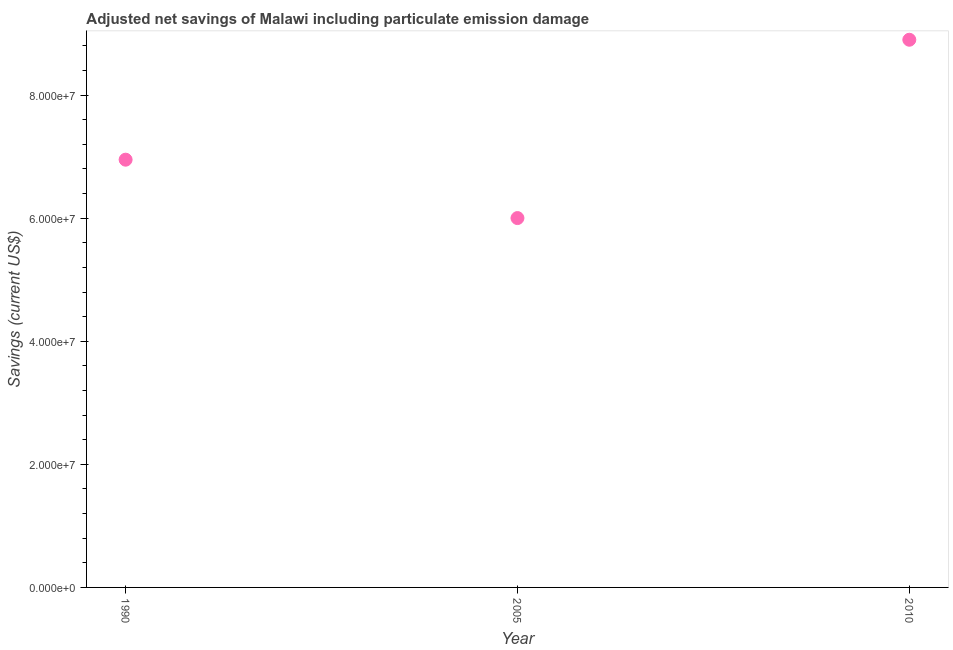What is the adjusted net savings in 2010?
Offer a very short reply. 8.90e+07. Across all years, what is the maximum adjusted net savings?
Provide a short and direct response. 8.90e+07. Across all years, what is the minimum adjusted net savings?
Provide a succinct answer. 6.00e+07. What is the sum of the adjusted net savings?
Your response must be concise. 2.19e+08. What is the difference between the adjusted net savings in 2005 and 2010?
Provide a short and direct response. -2.90e+07. What is the average adjusted net savings per year?
Your answer should be compact. 7.28e+07. What is the median adjusted net savings?
Offer a very short reply. 6.95e+07. In how many years, is the adjusted net savings greater than 52000000 US$?
Your answer should be compact. 3. What is the ratio of the adjusted net savings in 1990 to that in 2005?
Offer a very short reply. 1.16. What is the difference between the highest and the second highest adjusted net savings?
Your response must be concise. 1.95e+07. What is the difference between the highest and the lowest adjusted net savings?
Provide a succinct answer. 2.90e+07. In how many years, is the adjusted net savings greater than the average adjusted net savings taken over all years?
Your answer should be compact. 1. How many dotlines are there?
Offer a very short reply. 1. What is the difference between two consecutive major ticks on the Y-axis?
Make the answer very short. 2.00e+07. Are the values on the major ticks of Y-axis written in scientific E-notation?
Provide a short and direct response. Yes. Does the graph contain any zero values?
Ensure brevity in your answer.  No. Does the graph contain grids?
Ensure brevity in your answer.  No. What is the title of the graph?
Your response must be concise. Adjusted net savings of Malawi including particulate emission damage. What is the label or title of the X-axis?
Provide a succinct answer. Year. What is the label or title of the Y-axis?
Make the answer very short. Savings (current US$). What is the Savings (current US$) in 1990?
Your answer should be very brief. 6.95e+07. What is the Savings (current US$) in 2005?
Offer a terse response. 6.00e+07. What is the Savings (current US$) in 2010?
Make the answer very short. 8.90e+07. What is the difference between the Savings (current US$) in 1990 and 2005?
Offer a very short reply. 9.49e+06. What is the difference between the Savings (current US$) in 1990 and 2010?
Offer a terse response. -1.95e+07. What is the difference between the Savings (current US$) in 2005 and 2010?
Make the answer very short. -2.90e+07. What is the ratio of the Savings (current US$) in 1990 to that in 2005?
Offer a very short reply. 1.16. What is the ratio of the Savings (current US$) in 1990 to that in 2010?
Your response must be concise. 0.78. What is the ratio of the Savings (current US$) in 2005 to that in 2010?
Give a very brief answer. 0.67. 